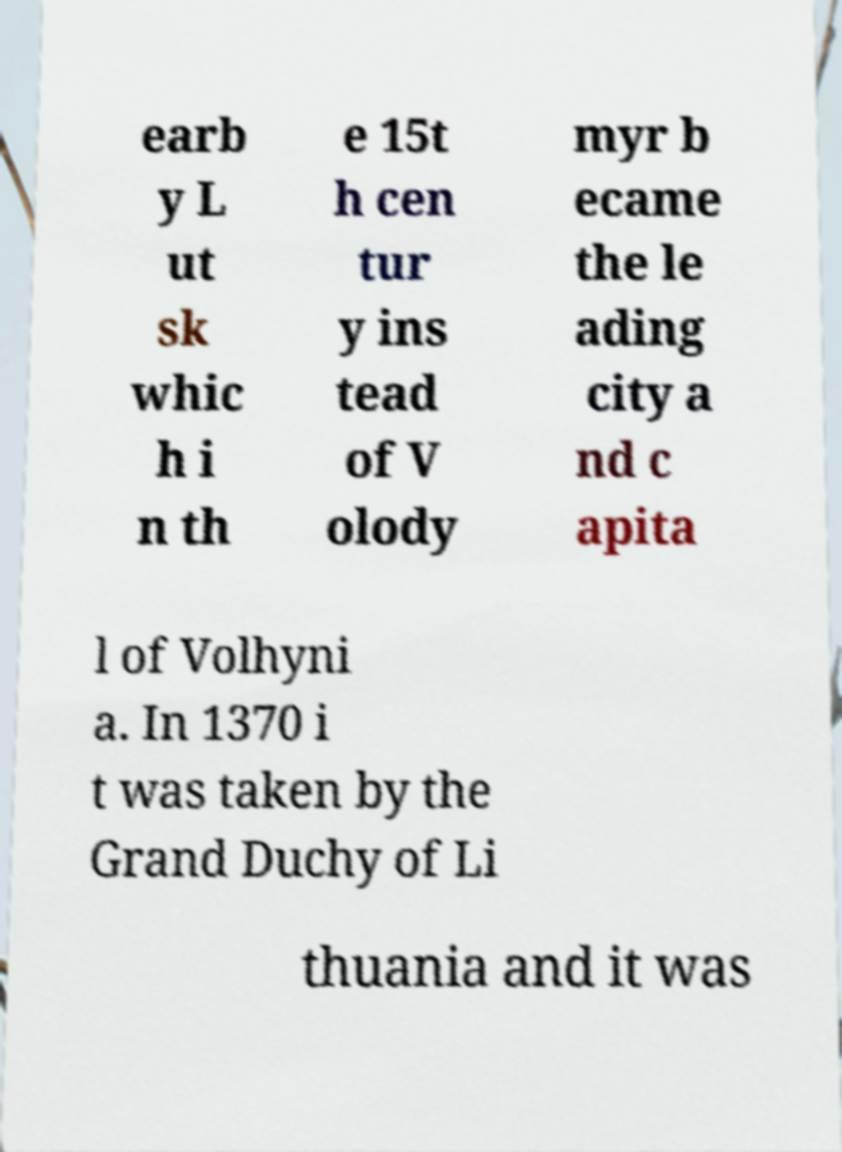Could you extract and type out the text from this image? earb y L ut sk whic h i n th e 15t h cen tur y ins tead of V olody myr b ecame the le ading city a nd c apita l of Volhyni a. In 1370 i t was taken by the Grand Duchy of Li thuania and it was 